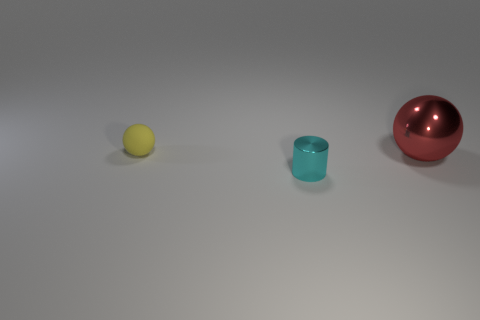Add 3 big spheres. How many objects exist? 6 Subtract all blue cylinders. How many red spheres are left? 1 Subtract all yellow spheres. How many spheres are left? 1 Subtract 2 balls. How many balls are left? 0 Subtract all cyan balls. Subtract all cyan cylinders. How many balls are left? 2 Add 3 small yellow objects. How many small yellow objects are left? 4 Add 1 yellow rubber spheres. How many yellow rubber spheres exist? 2 Subtract 1 red balls. How many objects are left? 2 Subtract all spheres. How many objects are left? 1 Subtract all big red spheres. Subtract all tiny yellow matte things. How many objects are left? 1 